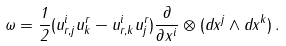Convert formula to latex. <formula><loc_0><loc_0><loc_500><loc_500>\omega = \frac { 1 } { 2 } ( u ^ { i } _ { r , j } u ^ { r } _ { k } - u ^ { i } _ { r , k } u ^ { r } _ { j } ) \frac { \partial } { \partial x ^ { i } } \otimes ( d x ^ { j } \wedge d x ^ { k } ) \, .</formula> 